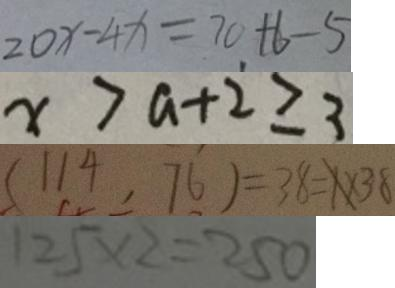Convert formula to latex. <formula><loc_0><loc_0><loc_500><loc_500>2 0 x - 4 x = 7 0 + 6 - 5 
 x > a + 2 \geqslant 3 
 ( 1 1 4 , 7 6 ) = 3 8 = X \times 3 8 
 1 2 5 \times 2 = 2 5 0</formula> 